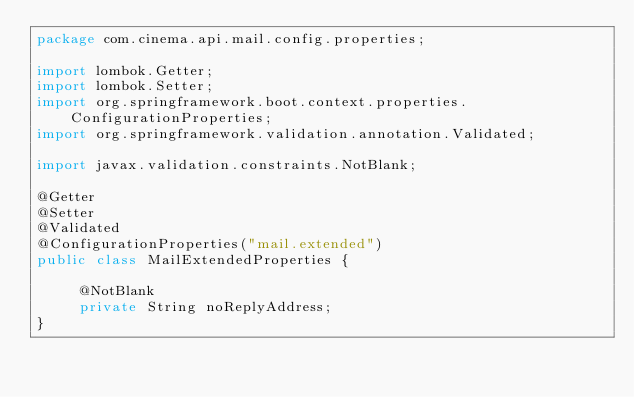Convert code to text. <code><loc_0><loc_0><loc_500><loc_500><_Java_>package com.cinema.api.mail.config.properties;

import lombok.Getter;
import lombok.Setter;
import org.springframework.boot.context.properties.ConfigurationProperties;
import org.springframework.validation.annotation.Validated;

import javax.validation.constraints.NotBlank;

@Getter
@Setter
@Validated
@ConfigurationProperties("mail.extended")
public class MailExtendedProperties {

     @NotBlank
     private String noReplyAddress;
}
</code> 